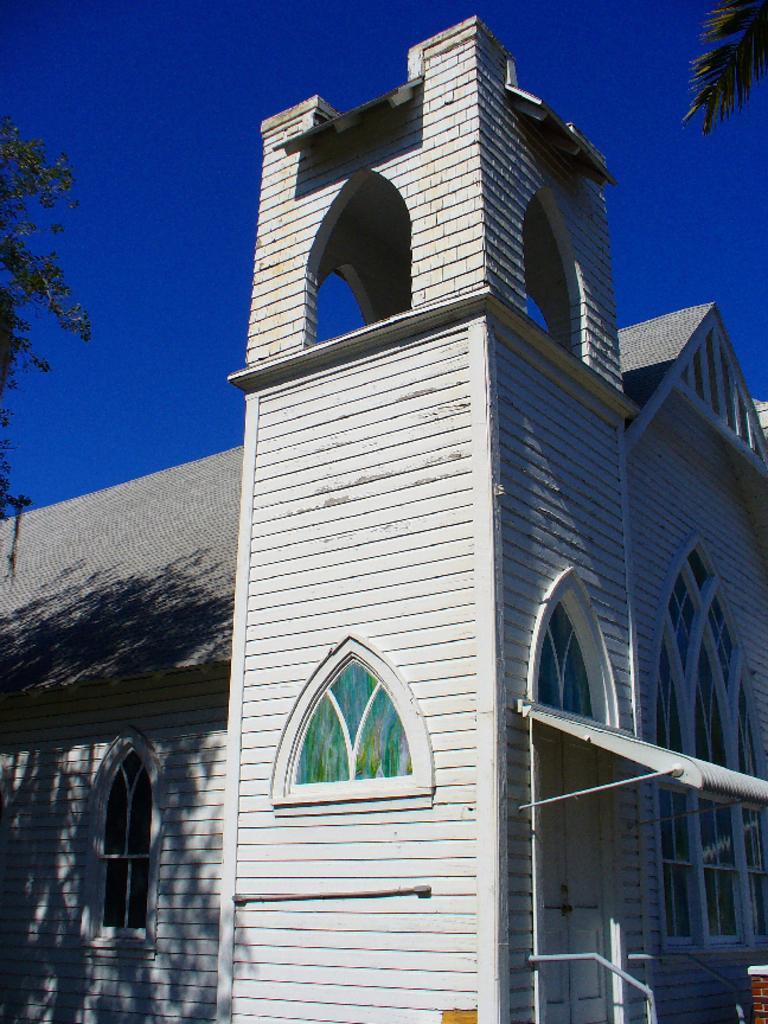In one or two sentences, can you explain what this image depicts? In this image I can see the building with windows. On both sides of the building I can see the trees. In the background I can see the blue sky. 